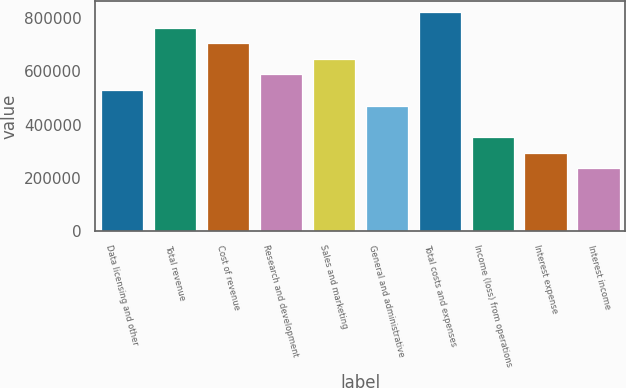<chart> <loc_0><loc_0><loc_500><loc_500><bar_chart><fcel>Data licensing and other<fcel>Total revenue<fcel>Cost of revenue<fcel>Research and development<fcel>Sales and marketing<fcel>General and administrative<fcel>Total costs and expenses<fcel>Income (loss) from operations<fcel>Interest expense<fcel>Interest income<nl><fcel>529676<fcel>765088<fcel>706235<fcel>588529<fcel>647382<fcel>470823<fcel>823941<fcel>353117<fcel>294265<fcel>235412<nl></chart> 